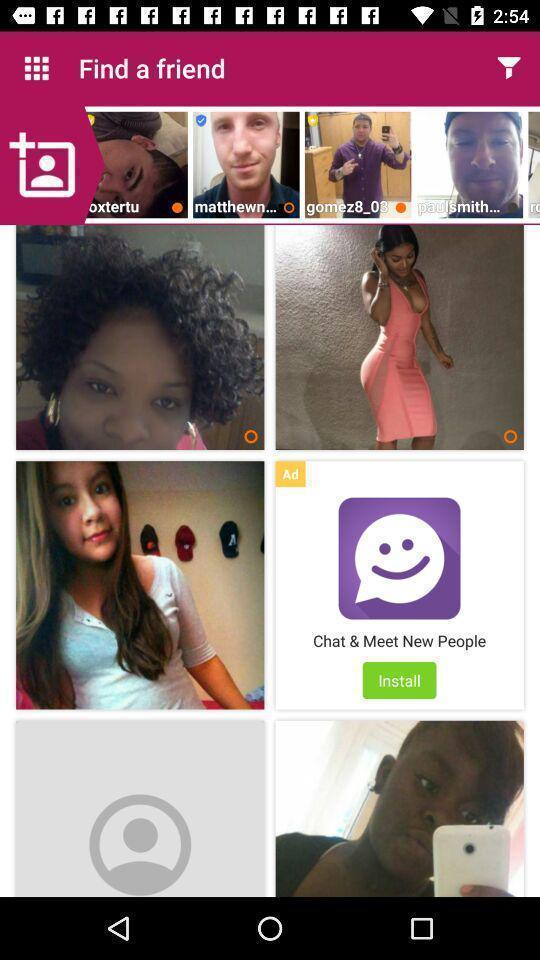Summarize the main components in this picture. Page for finding friends in a dating app. 